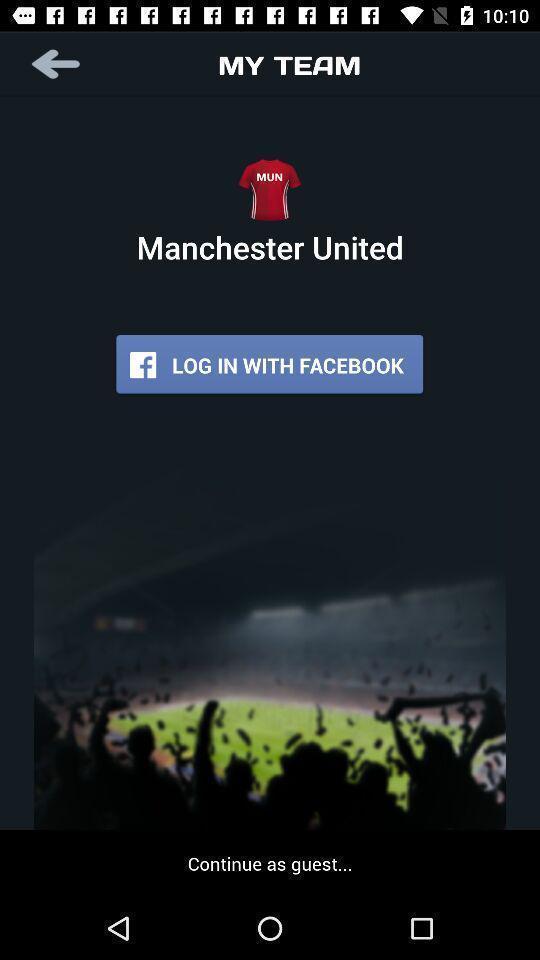Summarize the information in this screenshot. Welcome page displaying options to login into account. 